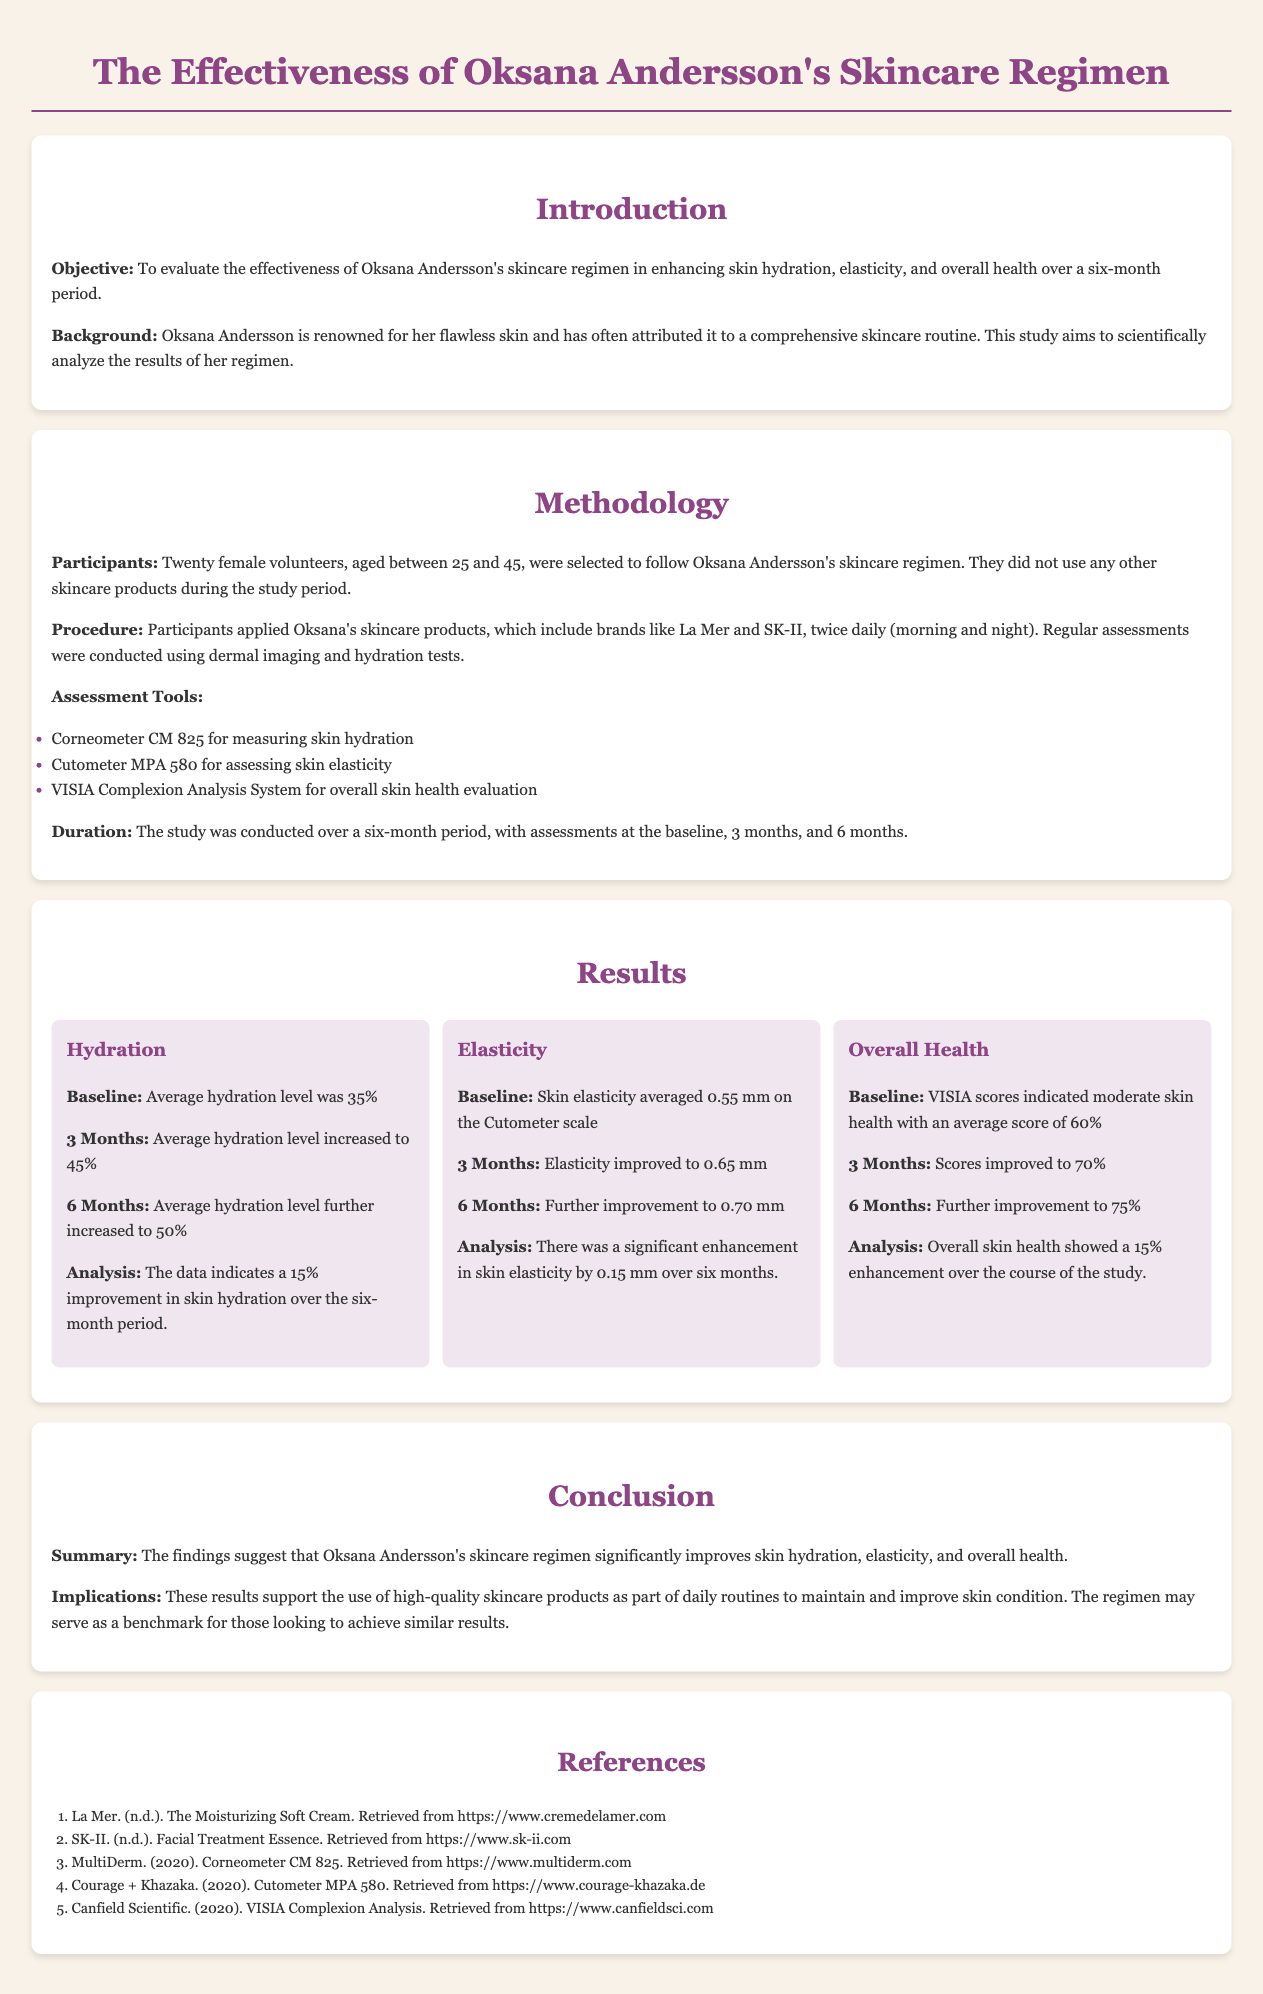What was the average hydration level at baseline? The average hydration level at baseline was 35%.
Answer: 35% How many participants were involved in the study? The document states that twenty female volunteers were selected for the study.
Answer: Twenty What tool was used to measure skin hydration? The method section specifies that the Corneometer CM 825 was used for measuring skin hydration.
Answer: Corneometer CM 825 What was the elastic improvement recorded at six months? The results show that skin elasticity improved to 0.70 mm at six months.
Answer: 0.70 mm What was the average VISIA score at three months? The results indicate that the average VISIA score improved to 70% at three months.
Answer: 70% What skincare brands were mentioned in Oksana's regimen? The study mentions La Mer and SK-II as brands included in Oksana's skincare regimen.
Answer: La Mer and SK-II What overall improvement in skin health was reported? The conclusion section summarizes that there was a 15% enhancement in overall skin health.
Answer: 15% What was the duration of the study? The methodology section specifies that the study was conducted over a six-month period.
Answer: Six months 